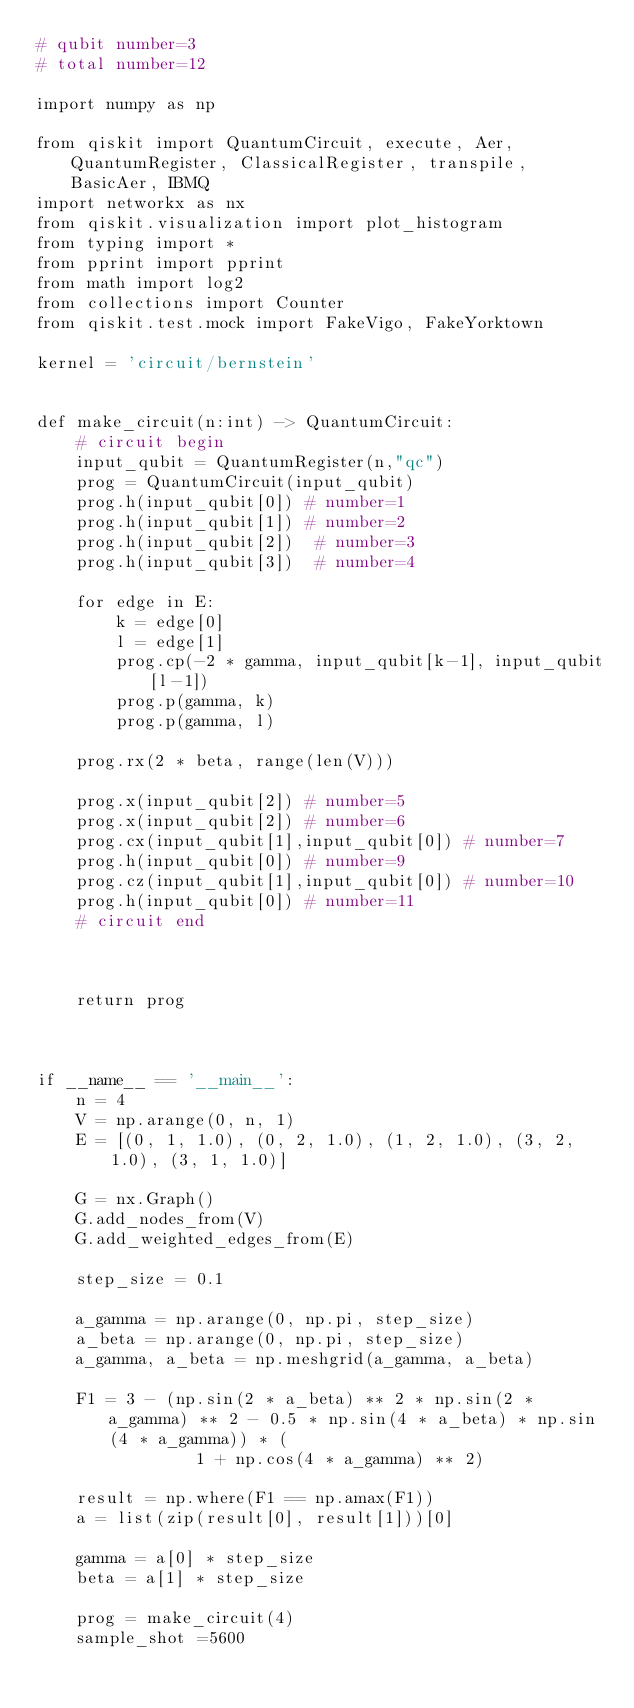Convert code to text. <code><loc_0><loc_0><loc_500><loc_500><_Python_># qubit number=3
# total number=12

import numpy as np

from qiskit import QuantumCircuit, execute, Aer, QuantumRegister, ClassicalRegister, transpile, BasicAer, IBMQ
import networkx as nx
from qiskit.visualization import plot_histogram
from typing import *
from pprint import pprint
from math import log2
from collections import Counter
from qiskit.test.mock import FakeVigo, FakeYorktown

kernel = 'circuit/bernstein'


def make_circuit(n:int) -> QuantumCircuit:
    # circuit begin
    input_qubit = QuantumRegister(n,"qc")
    prog = QuantumCircuit(input_qubit)
    prog.h(input_qubit[0]) # number=1
    prog.h(input_qubit[1]) # number=2
    prog.h(input_qubit[2])  # number=3
    prog.h(input_qubit[3])  # number=4

    for edge in E:
        k = edge[0]
        l = edge[1]
        prog.cp(-2 * gamma, input_qubit[k-1], input_qubit[l-1])
        prog.p(gamma, k)
        prog.p(gamma, l)

    prog.rx(2 * beta, range(len(V)))

    prog.x(input_qubit[2]) # number=5
    prog.x(input_qubit[2]) # number=6
    prog.cx(input_qubit[1],input_qubit[0]) # number=7
    prog.h(input_qubit[0]) # number=9
    prog.cz(input_qubit[1],input_qubit[0]) # number=10
    prog.h(input_qubit[0]) # number=11
    # circuit end



    return prog



if __name__ == '__main__':
    n = 4
    V = np.arange(0, n, 1)
    E = [(0, 1, 1.0), (0, 2, 1.0), (1, 2, 1.0), (3, 2, 1.0), (3, 1, 1.0)]

    G = nx.Graph()
    G.add_nodes_from(V)
    G.add_weighted_edges_from(E)

    step_size = 0.1

    a_gamma = np.arange(0, np.pi, step_size)
    a_beta = np.arange(0, np.pi, step_size)
    a_gamma, a_beta = np.meshgrid(a_gamma, a_beta)

    F1 = 3 - (np.sin(2 * a_beta) ** 2 * np.sin(2 * a_gamma) ** 2 - 0.5 * np.sin(4 * a_beta) * np.sin(4 * a_gamma)) * (
                1 + np.cos(4 * a_gamma) ** 2)

    result = np.where(F1 == np.amax(F1))
    a = list(zip(result[0], result[1]))[0]

    gamma = a[0] * step_size
    beta = a[1] * step_size

    prog = make_circuit(4)
    sample_shot =5600</code> 